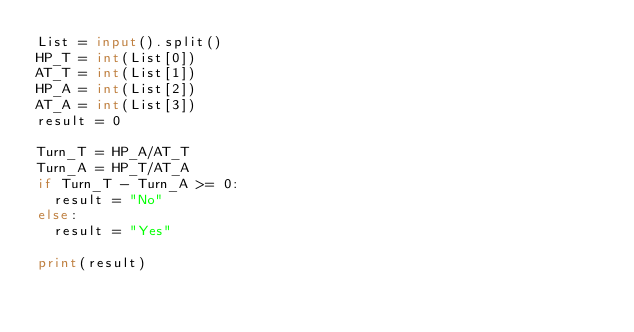Convert code to text. <code><loc_0><loc_0><loc_500><loc_500><_Python_>List = input().split()
HP_T = int(List[0])
AT_T = int(List[1])
HP_A = int(List[2])
AT_A = int(List[3])
result = 0

Turn_T = HP_A/AT_T 
Turn_A = HP_T/AT_A 
if Turn_T - Turn_A >= 0:
  result = "No"
else:
  result = "Yes"

print(result)</code> 